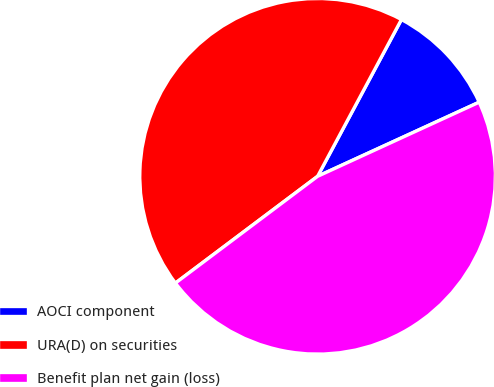<chart> <loc_0><loc_0><loc_500><loc_500><pie_chart><fcel>AOCI component<fcel>URA(D) on securities<fcel>Benefit plan net gain (loss)<nl><fcel>10.34%<fcel>43.07%<fcel>46.6%<nl></chart> 